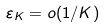Convert formula to latex. <formula><loc_0><loc_0><loc_500><loc_500>\varepsilon _ { K } = o ( 1 / K )</formula> 